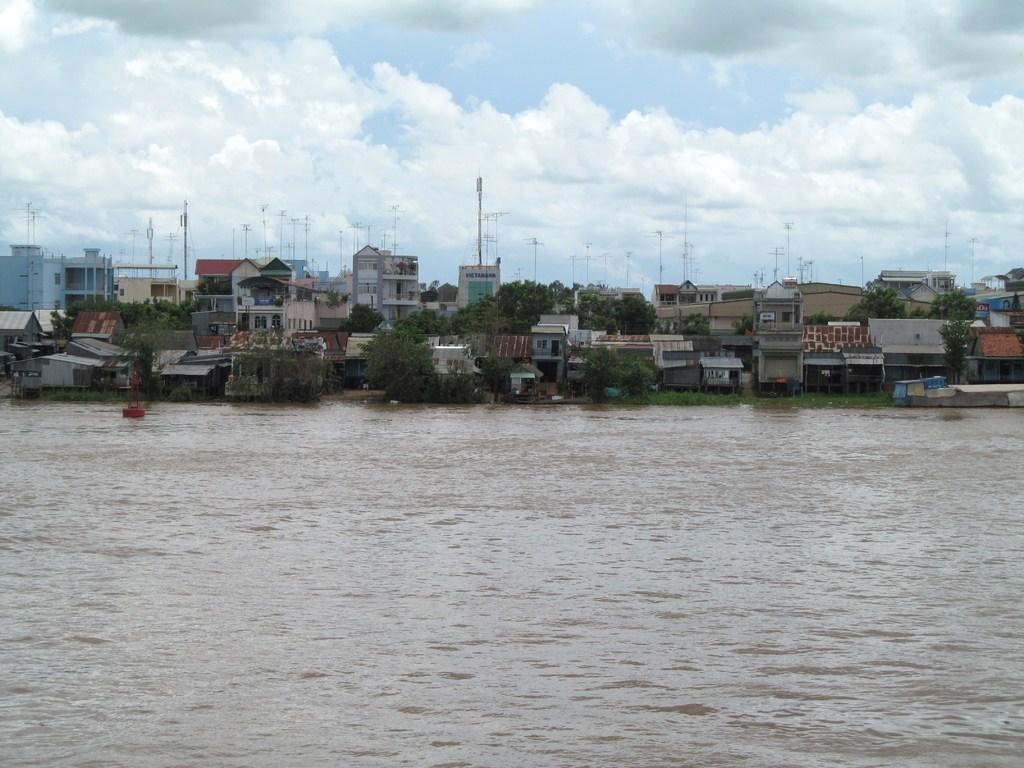How would you summarize this image in a sentence or two? In this image there is a river and we can see buildings and trees. There are poles. In the background there is sky. 